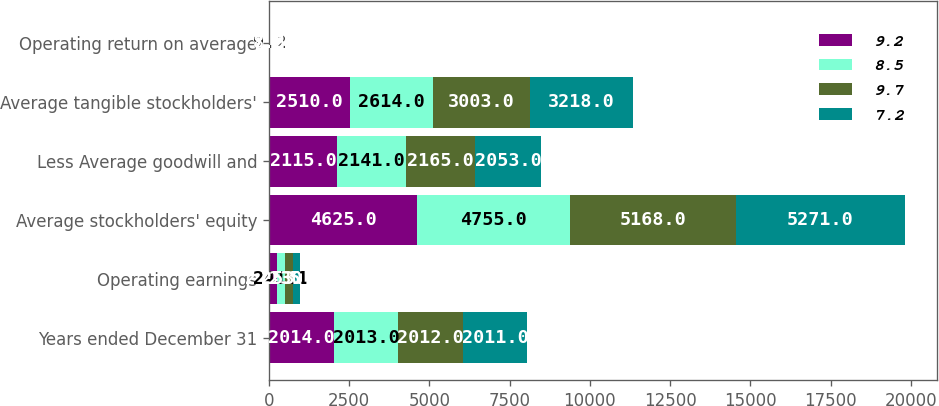<chart> <loc_0><loc_0><loc_500><loc_500><stacked_bar_chart><ecel><fcel>Years ended December 31<fcel>Operating earnings<fcel>Average stockholders' equity<fcel>Less Average goodwill and<fcel>Average tangible stockholders'<fcel>Operating return on average<nl><fcel>9.2<fcel>2014<fcel>244.5<fcel>4625<fcel>2115<fcel>2510<fcel>9.7<nl><fcel>8.5<fcel>2013<fcel>241.1<fcel>4755<fcel>2141<fcel>2614<fcel>9.2<nl><fcel>9.7<fcel>2012<fcel>253.9<fcel>5168<fcel>2165<fcel>3003<fcel>8.5<nl><fcel>7.2<fcel>2011<fcel>230.7<fcel>5271<fcel>2053<fcel>3218<fcel>7.2<nl></chart> 